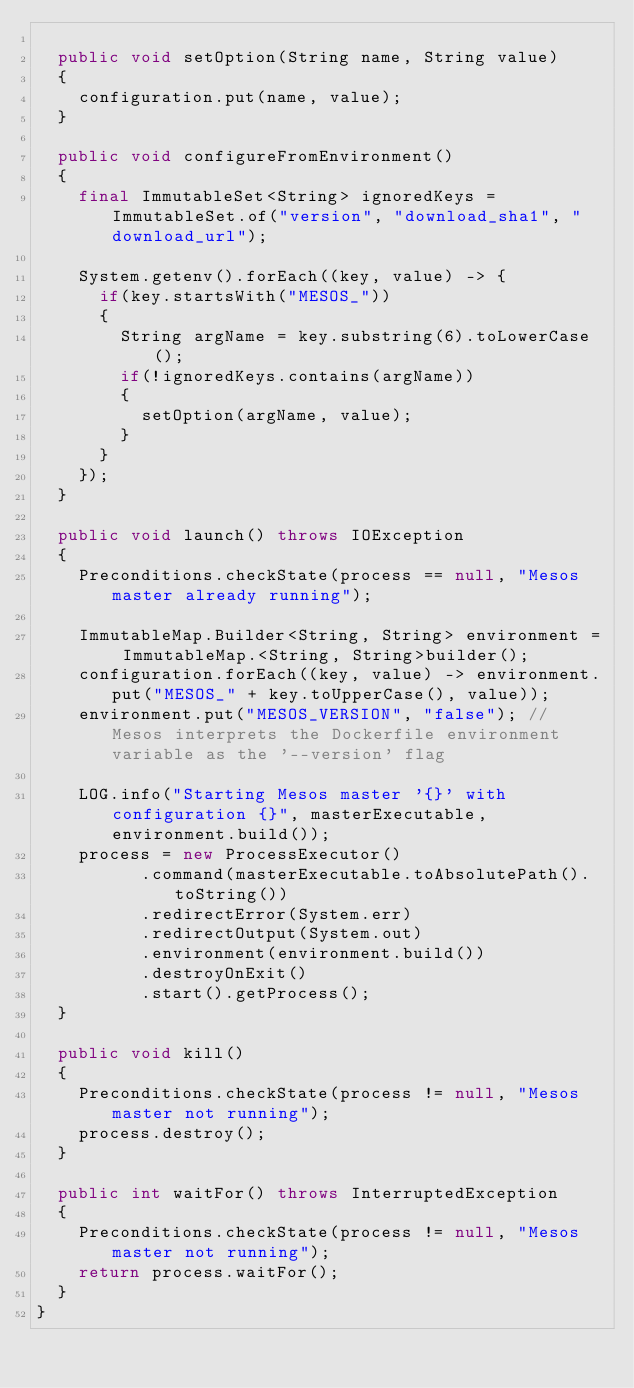<code> <loc_0><loc_0><loc_500><loc_500><_Java_>
	public void setOption(String name, String value)
	{
		configuration.put(name, value);
	}

	public void configureFromEnvironment()
	{
		final ImmutableSet<String> ignoredKeys = ImmutableSet.of("version", "download_sha1", "download_url");

		System.getenv().forEach((key, value) -> {
			if(key.startsWith("MESOS_"))
			{
				String argName = key.substring(6).toLowerCase();
				if(!ignoredKeys.contains(argName))
				{
					setOption(argName, value);
				}
			}
		});
	}

	public void launch() throws IOException
	{
		Preconditions.checkState(process == null, "Mesos master already running");

		ImmutableMap.Builder<String, String> environment = ImmutableMap.<String, String>builder();
		configuration.forEach((key, value) -> environment.put("MESOS_" + key.toUpperCase(), value));
		environment.put("MESOS_VERSION", "false"); // Mesos interprets the Dockerfile environment variable as the '--version' flag

		LOG.info("Starting Mesos master '{}' with configuration {}", masterExecutable, environment.build());
		process = new ProcessExecutor()
	        .command(masterExecutable.toAbsolutePath().toString())
	        .redirectError(System.err)
	        .redirectOutput(System.out)
	        .environment(environment.build())
	        .destroyOnExit()
	        .start().getProcess();
	}

	public void kill()
	{
		Preconditions.checkState(process != null, "Mesos master not running");
		process.destroy();
	}

	public int waitFor() throws InterruptedException
	{
		Preconditions.checkState(process != null, "Mesos master not running");
		return process.waitFor();
	}
}
</code> 